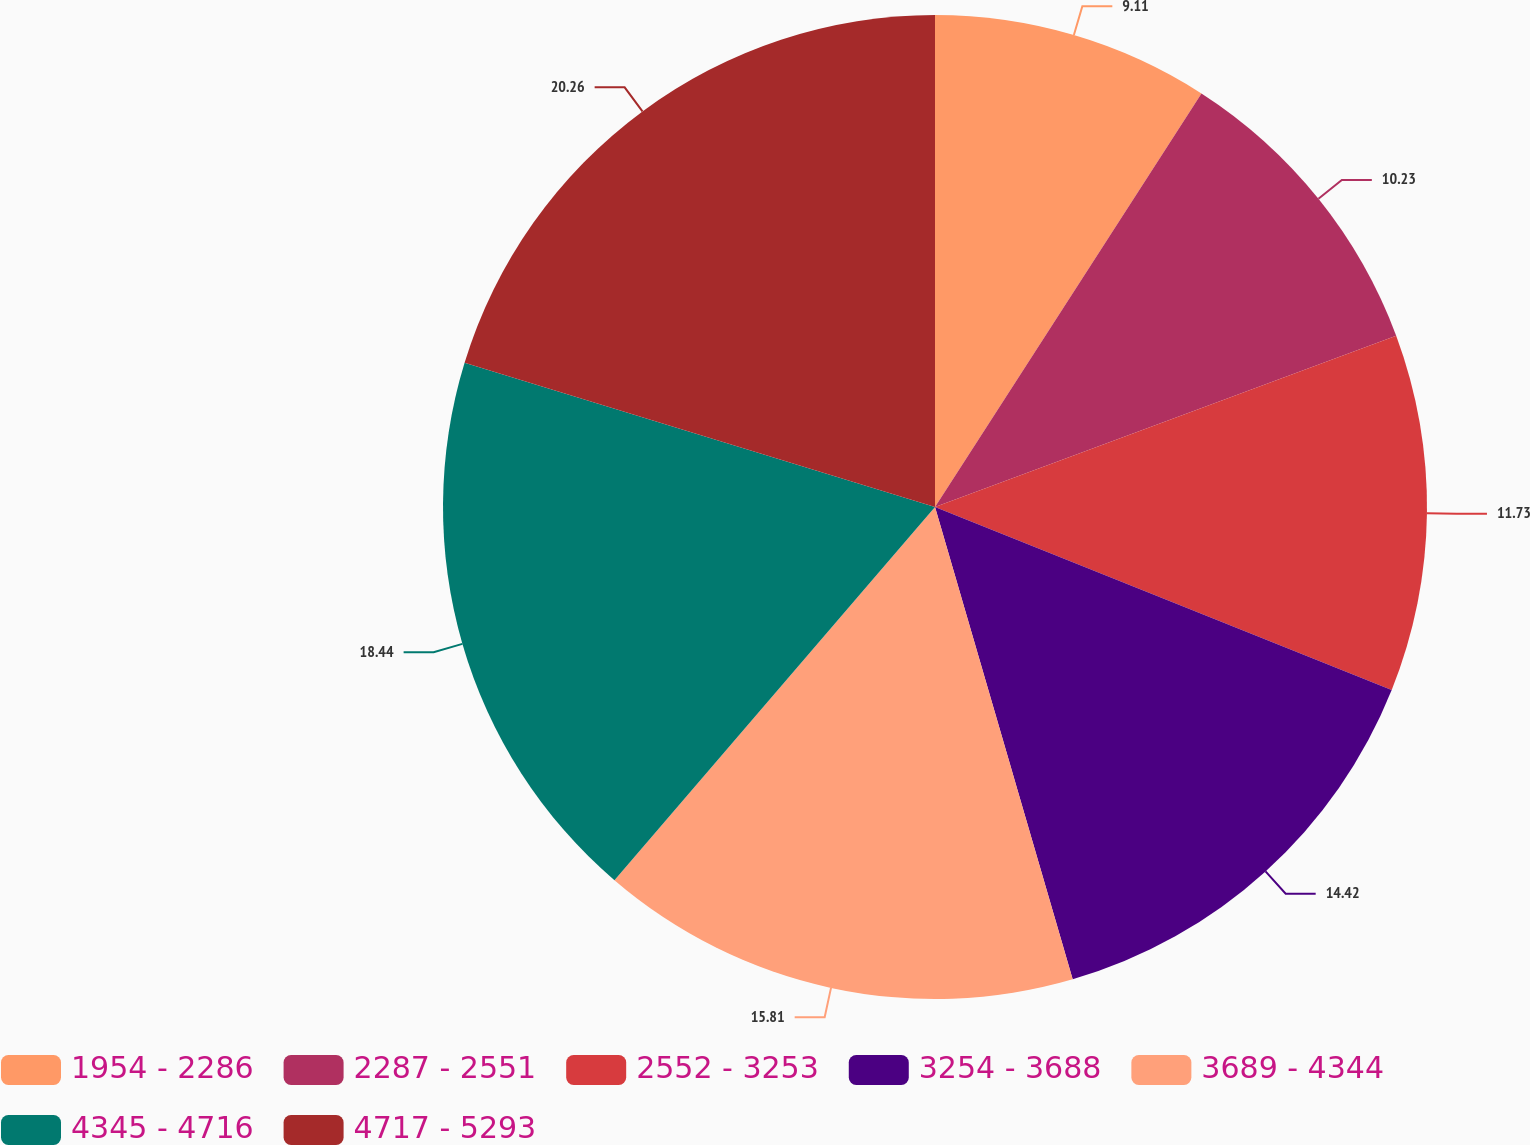Convert chart. <chart><loc_0><loc_0><loc_500><loc_500><pie_chart><fcel>1954 - 2286<fcel>2287 - 2551<fcel>2552 - 3253<fcel>3254 - 3688<fcel>3689 - 4344<fcel>4345 - 4716<fcel>4717 - 5293<nl><fcel>9.11%<fcel>10.23%<fcel>11.73%<fcel>14.42%<fcel>15.81%<fcel>18.44%<fcel>20.27%<nl></chart> 